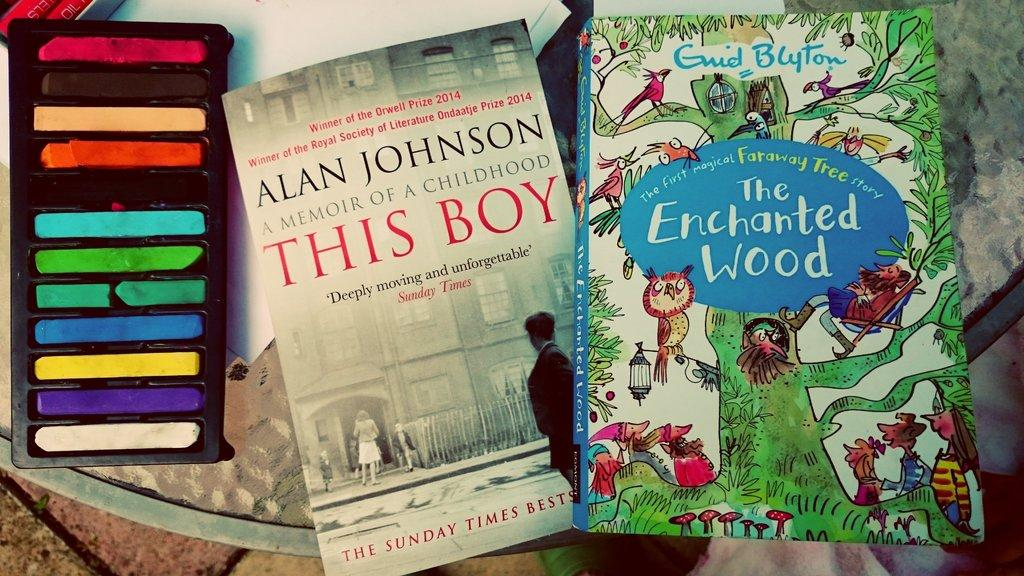<image>
Render a clear and concise summary of the photo. A book by Alan Johnson has another book next to it. 